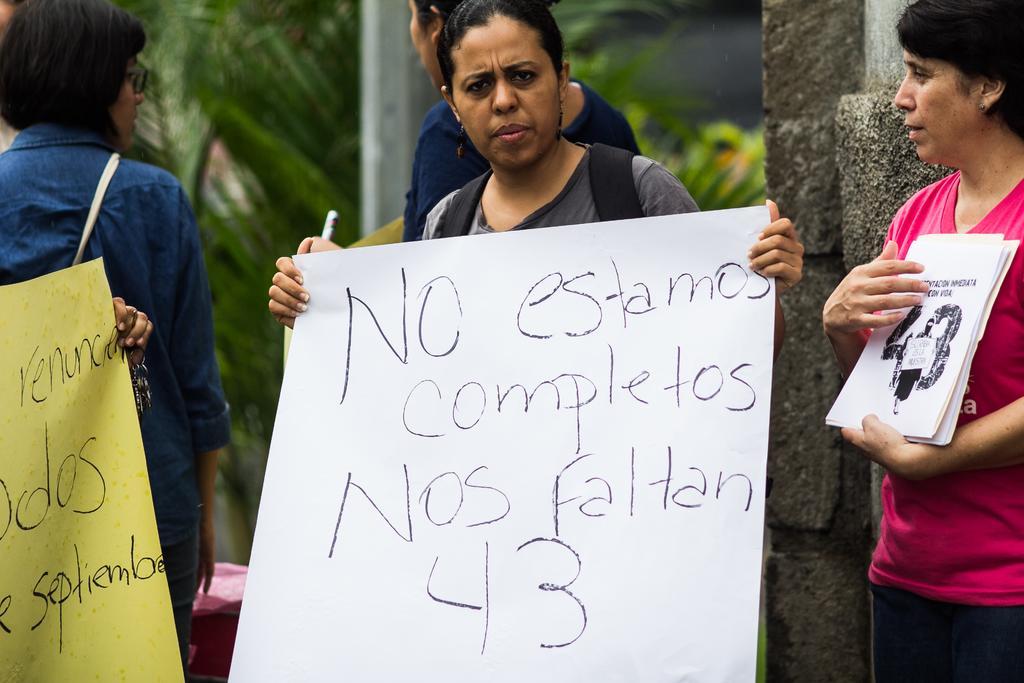Please provide a concise description of this image. in the given image i can see three women's standing and towards my left there is a women and middle women she is holding a bag and message which states no s completes towards my right i can women wearing pink color t shirt and holding books. i will build my bricks 